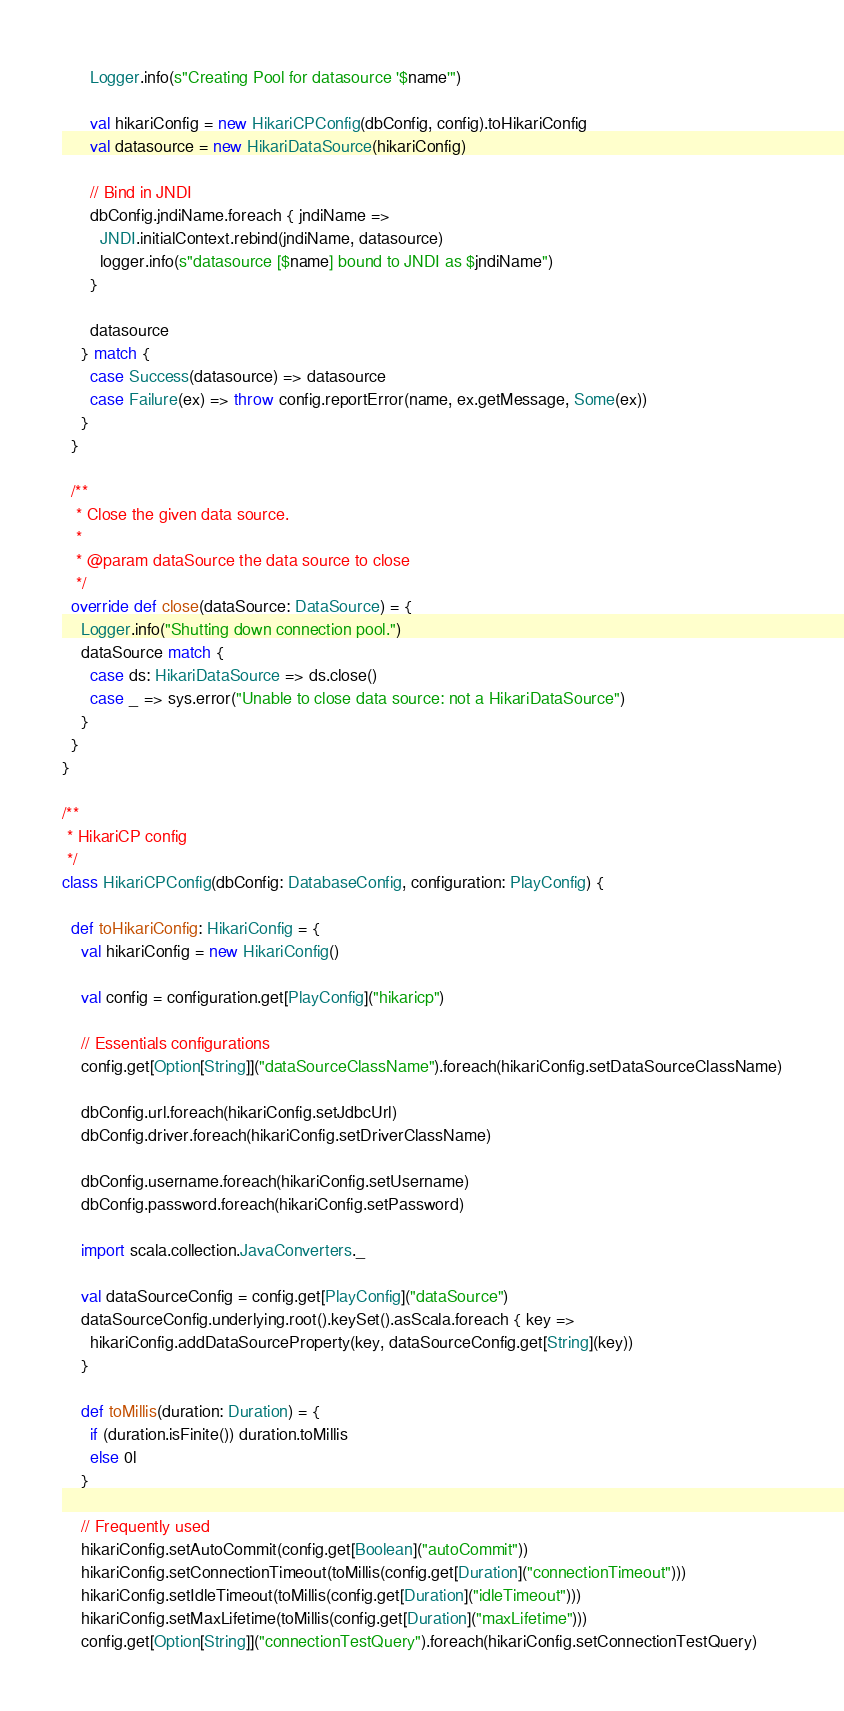Convert code to text. <code><loc_0><loc_0><loc_500><loc_500><_Scala_>      Logger.info(s"Creating Pool for datasource '$name'")

      val hikariConfig = new HikariCPConfig(dbConfig, config).toHikariConfig
      val datasource = new HikariDataSource(hikariConfig)

      // Bind in JNDI
      dbConfig.jndiName.foreach { jndiName =>
        JNDI.initialContext.rebind(jndiName, datasource)
        logger.info(s"datasource [$name] bound to JNDI as $jndiName")
      }

      datasource
    } match {
      case Success(datasource) => datasource
      case Failure(ex) => throw config.reportError(name, ex.getMessage, Some(ex))
    }
  }

  /**
   * Close the given data source.
   *
   * @param dataSource the data source to close
   */
  override def close(dataSource: DataSource) = {
    Logger.info("Shutting down connection pool.")
    dataSource match {
      case ds: HikariDataSource => ds.close()
      case _ => sys.error("Unable to close data source: not a HikariDataSource")
    }
  }
}

/**
 * HikariCP config
 */
class HikariCPConfig(dbConfig: DatabaseConfig, configuration: PlayConfig) {

  def toHikariConfig: HikariConfig = {
    val hikariConfig = new HikariConfig()

    val config = configuration.get[PlayConfig]("hikaricp")

    // Essentials configurations
    config.get[Option[String]]("dataSourceClassName").foreach(hikariConfig.setDataSourceClassName)

    dbConfig.url.foreach(hikariConfig.setJdbcUrl)
    dbConfig.driver.foreach(hikariConfig.setDriverClassName)

    dbConfig.username.foreach(hikariConfig.setUsername)
    dbConfig.password.foreach(hikariConfig.setPassword)

    import scala.collection.JavaConverters._

    val dataSourceConfig = config.get[PlayConfig]("dataSource")
    dataSourceConfig.underlying.root().keySet().asScala.foreach { key =>
      hikariConfig.addDataSourceProperty(key, dataSourceConfig.get[String](key))
    }

    def toMillis(duration: Duration) = {
      if (duration.isFinite()) duration.toMillis
      else 0l
    }

    // Frequently used
    hikariConfig.setAutoCommit(config.get[Boolean]("autoCommit"))
    hikariConfig.setConnectionTimeout(toMillis(config.get[Duration]("connectionTimeout")))
    hikariConfig.setIdleTimeout(toMillis(config.get[Duration]("idleTimeout")))
    hikariConfig.setMaxLifetime(toMillis(config.get[Duration]("maxLifetime")))
    config.get[Option[String]]("connectionTestQuery").foreach(hikariConfig.setConnectionTestQuery)</code> 